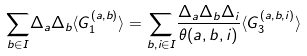<formula> <loc_0><loc_0><loc_500><loc_500>\underset { b \in I } { \sum } \Delta _ { a } \Delta _ { b } \langle G _ { 1 } ^ { ( a , b ) } \rangle = \underset { b , i \in I } { \sum } \frac { \Delta _ { a } \Delta _ { b } \Delta _ { i } } { \theta ( a , b , i ) } \langle G _ { 3 } ^ { ( a , b , i ) } \rangle</formula> 